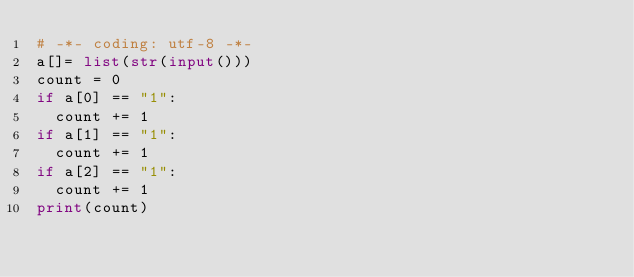Convert code to text. <code><loc_0><loc_0><loc_500><loc_500><_Python_># -*- coding: utf-8 -*-
a[]= list(str(input()))
count = 0
if a[0] == "1":
  count += 1
if a[1] == "1":
  count += 1
if a[2] == "1":
  count += 1
print(count)  
</code> 